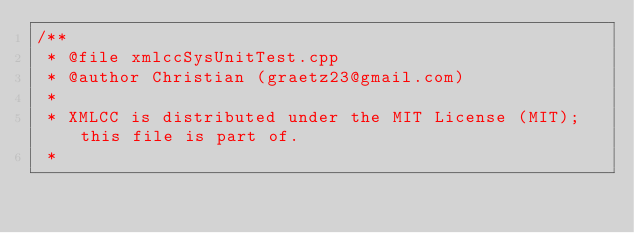Convert code to text. <code><loc_0><loc_0><loc_500><loc_500><_C++_>/** 
 * @file xmlccSysUnitTest.cpp
 * @author Christian (graetz23@gmail.com)
 *
 * XMLCC is distributed under the MIT License (MIT); this file is part of.
 *</code> 